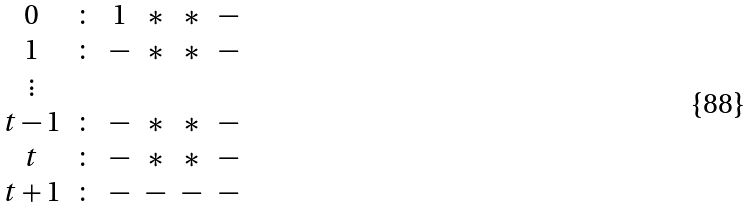<formula> <loc_0><loc_0><loc_500><loc_500>\begin{array} { c c c c c c c c c c c c c c c c c c c c c c } 0 & \colon & 1 & * & * & - \\ 1 & \colon & - & * & * & - \\ \vdots & & \\ t - 1 & \colon & - & * & * & - \\ t & \colon & - & * & * & - \\ t + 1 & \colon & - & - & - & - \end{array}</formula> 